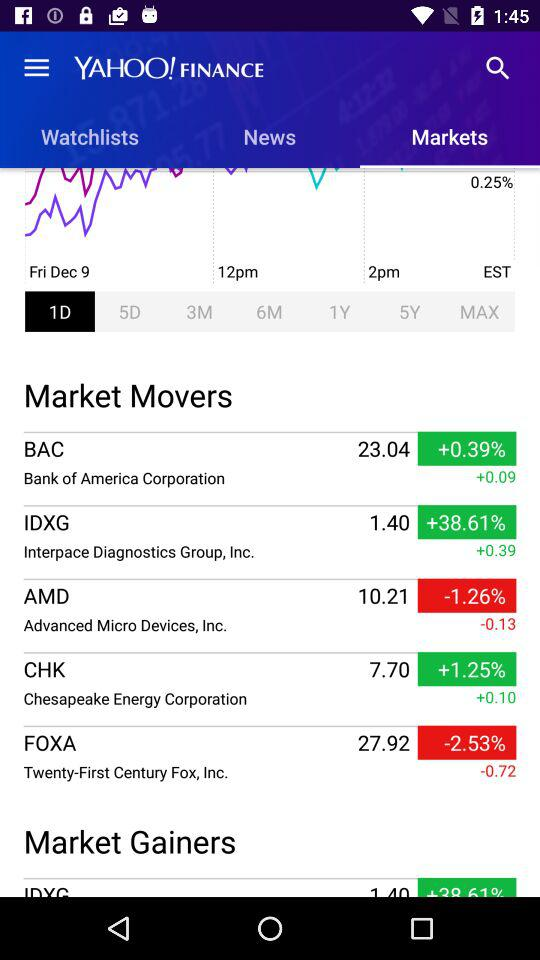What is the value of Bank of America Corporation? The value of "Bank of America Corporation" is 23.04. 